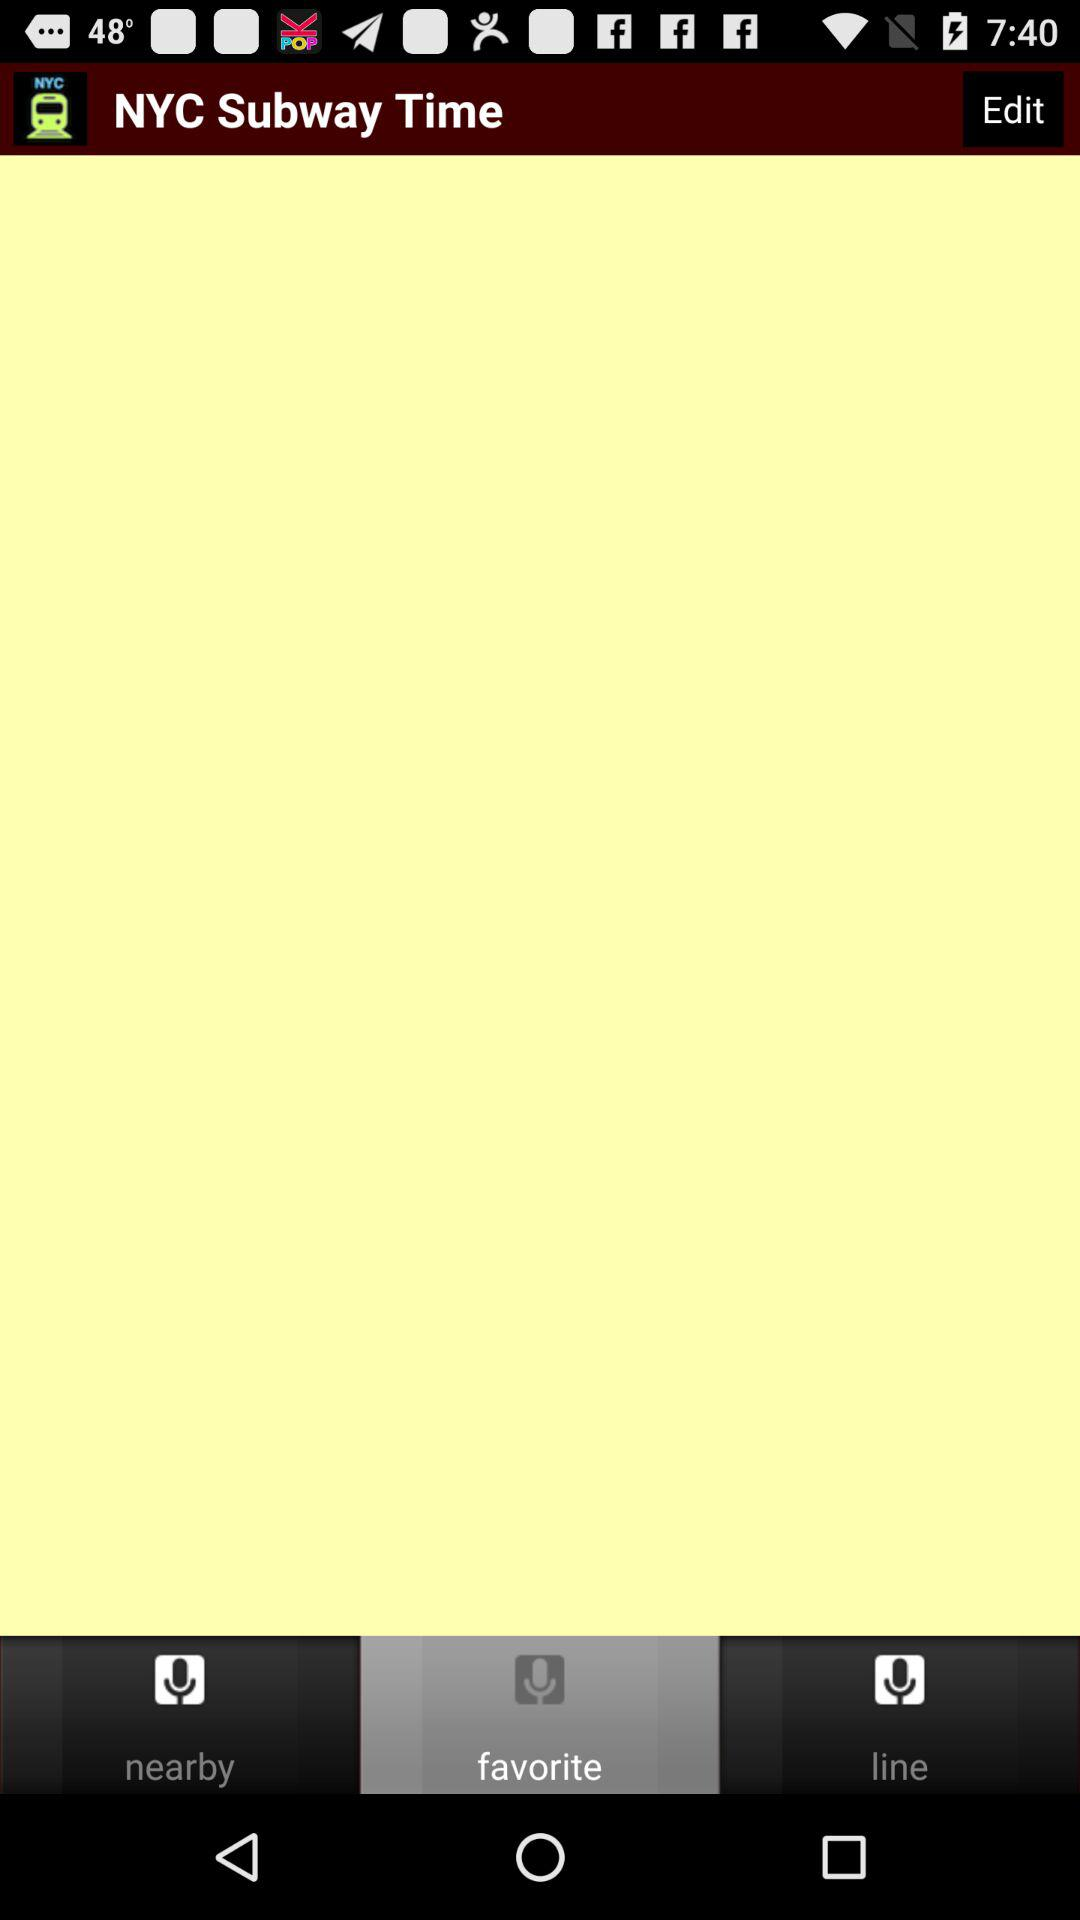What is the application name? The application name is "NYC Subway Time". 